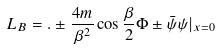<formula> <loc_0><loc_0><loc_500><loc_500>L _ { B } = . \pm \frac { 4 m } { \beta ^ { 2 } } \cos \frac { \beta } { 2 } \Phi \pm \bar { \psi } \psi | _ { x = 0 }</formula> 